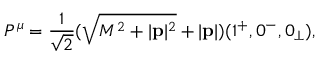<formula> <loc_0><loc_0><loc_500><loc_500>P ^ { \mu } = \frac { 1 } { \sqrt { 2 } } ( \sqrt { M ^ { 2 } + | { p } | ^ { 2 } } + | { p } | ) ( 1 ^ { + } , 0 ^ { - } , 0 _ { \perp } ) ,</formula> 